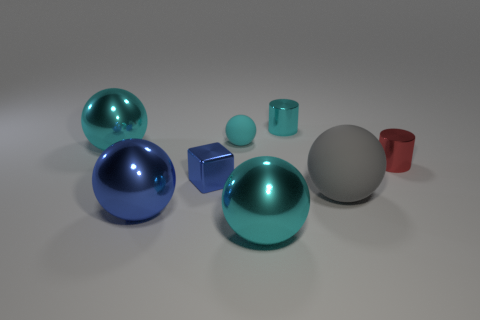Are any of these objects likely to interact with one another in a real-world setting? In a real-world setting, these objects might not interact with each other in any functional sense. They appear to be simple geometric shapes used more likely for display or stylistic purposes. However, if they were representative of real objects, such as toys or design elements, they could be arranged decoratively or used in educational settings to teach about shapes and spatial relationships. 